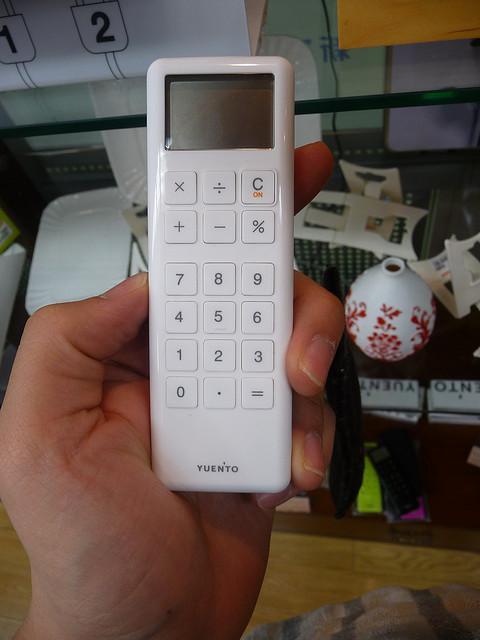What is this device used for?
Make your selection from the four choices given to correctly answer the question.
Options: Phone calls, music, arithmetic, video games. Arithmetic. 